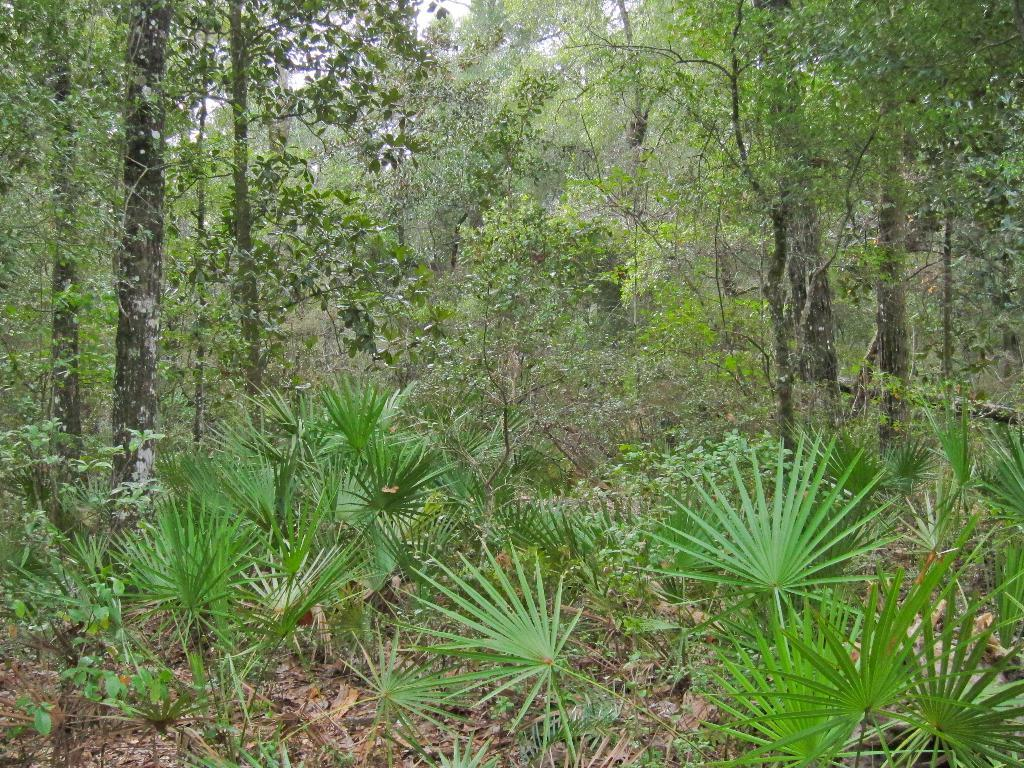What type of vegetation can be seen in the image? There are trees and plants on the ground in the image. Can you describe the plants on the ground? The plants on the ground are visible in the image, but their specific characteristics are not mentioned in the provided facts. What is the primary setting of the image? The primary setting of the image is outdoors, given the presence of trees and plants. How long does it take to hear the sound of the work being done in the image? There is no reference to any work or sound being done in the image, so it is not possible to answer that question. 